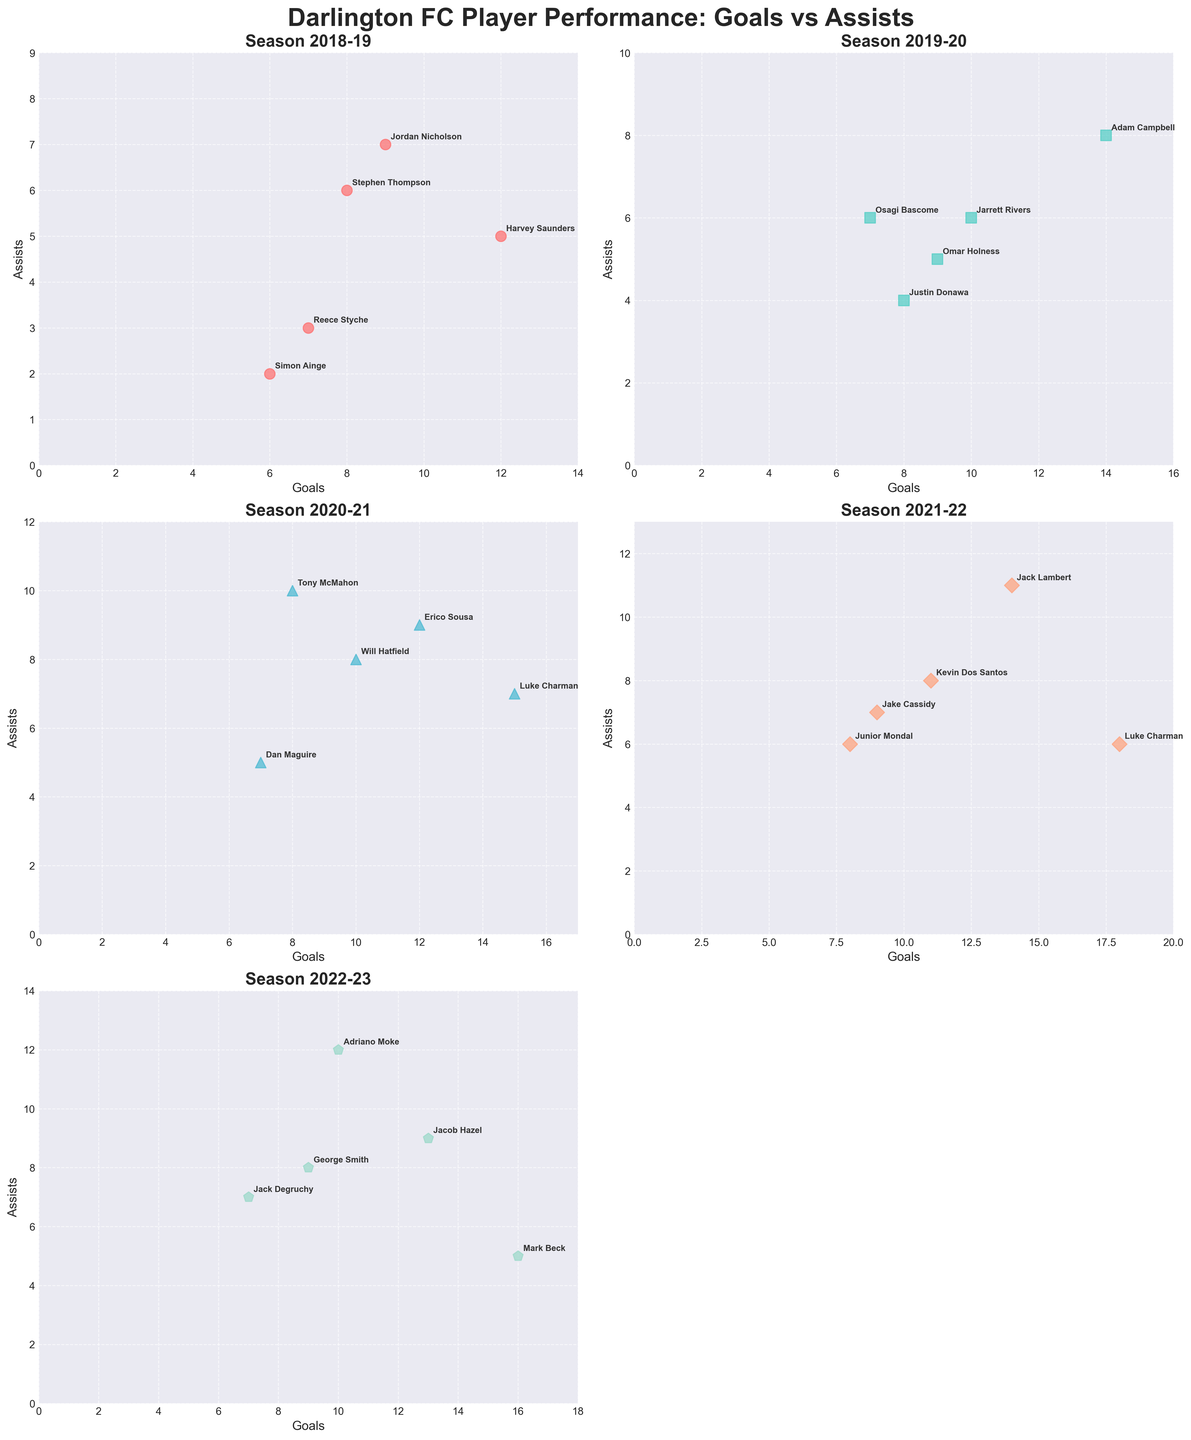Who had the highest number of goals in the 2019-20 season? To find the highest number of goals in the 2019-20 season, locate the subplot for that season and identify the player with the highest position on the Goals axis. Adam Campbell is at the highest point for goals.
Answer: Adam Campbell Which player had the most assists in the 2020-21 season? Check the subplot for the 2020-21 season and identify the player with the highest position on the Assists axis. Tony McMahon has the highest assists.
Answer: Tony McMahon Who had more assists in the 2021-22 season, Jack Lambert or Kevin Dos Santos? Locate the subplot for the 2021-22 season and compare the assists of Jack Lambert and Kevin Dos Santos. Jack Lambert has 11 assists, whereas Kevin Dos Santos has 8 assists.
Answer: Jack Lambert What's the average number of goals for the top 3 goalscorers in the 2022-23 season? In the 2022-23 subplot, the top 3 goalscorers are Mark Beck (16 goals), Jacob Hazel (13 goals), and Adriano Moke (10 goals). The average is calculated as (16 + 13 + 10) / 3 = 13.
Answer: 13 Which season had the player with the highest combined total of goals and assists, and who was the player? Examine each subplot to determine the player with the highest combined goals and assists. In the 2020-21 season, Luke Charman had 22 combined total (15 goals + 7 assists), and in the 2022-23 season, Adriano Moke had 22 combined total (10 goals + 12 assists).
Answer: 2022-23, Adriano Moke How did Luke Charman's performance compare in terms of goals between the 2020-21 and 2021-22 seasons? Compare Luke Charman's goals in the two seasons. In 2020-21, he scored 15 goals. In 2021-22, he scored 18 goals. So, he improved by 3 goals.
Answer: He scored 3 more goals in 2021-22 Which player had the equal number of goals and assists in the 2022-23 season? Identify the player in the 2022-23 subplot where the Goals and Assists are equal. Jack Degruchy had 7 goals and 7 assists.
Answer: Jack Degruchy Was there any season where the top scorer scored fewer than 10 goals? Check each subplot for the top scorer's goals. In all seasons, the top scorer had more than 10 goals.
Answer: No 